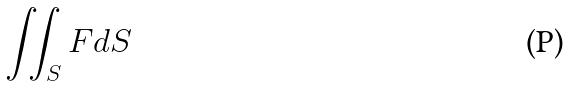Convert formula to latex. <formula><loc_0><loc_0><loc_500><loc_500>\iint _ { S } F d S</formula> 